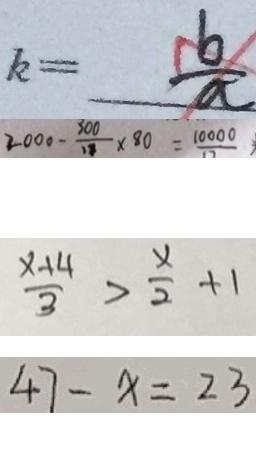Convert formula to latex. <formula><loc_0><loc_0><loc_500><loc_500>k = \frac { b } { a } 
 2 0 0 0 - \frac { 3 0 0 } { 1 8 } \times 8 0 = \frac { 1 0 0 0 0 } { 1 7 } 
 \frac { x + 4 } { 3 } > \frac { x } { 2 } + 1 
 4 7 - x = 2 3</formula> 